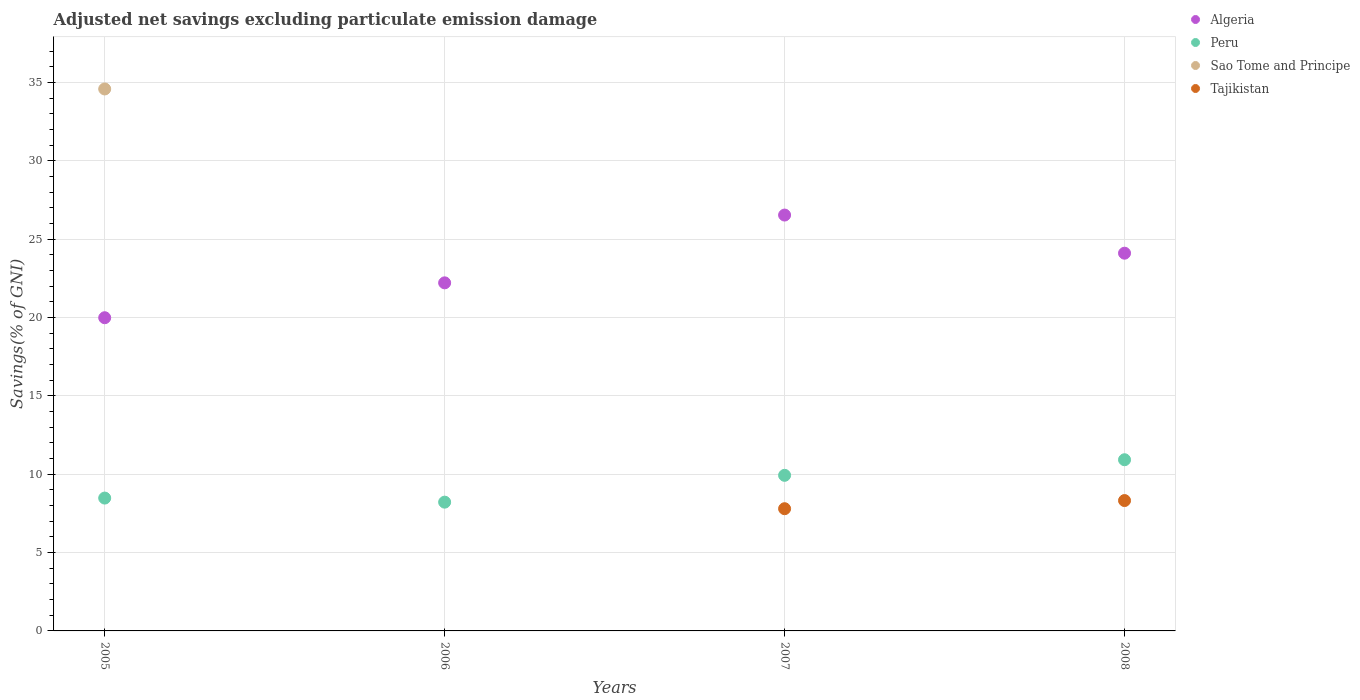How many different coloured dotlines are there?
Ensure brevity in your answer.  4. What is the adjusted net savings in Sao Tome and Principe in 2007?
Keep it short and to the point. 0. Across all years, what is the maximum adjusted net savings in Sao Tome and Principe?
Your answer should be very brief. 34.58. Across all years, what is the minimum adjusted net savings in Algeria?
Your answer should be compact. 19.99. What is the total adjusted net savings in Sao Tome and Principe in the graph?
Give a very brief answer. 34.58. What is the difference between the adjusted net savings in Peru in 2006 and that in 2007?
Your answer should be compact. -1.71. What is the difference between the adjusted net savings in Tajikistan in 2006 and the adjusted net savings in Algeria in 2008?
Provide a succinct answer. -24.1. What is the average adjusted net savings in Peru per year?
Provide a succinct answer. 9.39. In the year 2008, what is the difference between the adjusted net savings in Tajikistan and adjusted net savings in Algeria?
Provide a short and direct response. -15.78. In how many years, is the adjusted net savings in Tajikistan greater than 14 %?
Ensure brevity in your answer.  0. What is the ratio of the adjusted net savings in Peru in 2006 to that in 2007?
Your response must be concise. 0.83. What is the difference between the highest and the second highest adjusted net savings in Peru?
Keep it short and to the point. 0.99. What is the difference between the highest and the lowest adjusted net savings in Algeria?
Keep it short and to the point. 6.55. In how many years, is the adjusted net savings in Algeria greater than the average adjusted net savings in Algeria taken over all years?
Make the answer very short. 2. Is the sum of the adjusted net savings in Algeria in 2005 and 2006 greater than the maximum adjusted net savings in Tajikistan across all years?
Your response must be concise. Yes. Is it the case that in every year, the sum of the adjusted net savings in Sao Tome and Principe and adjusted net savings in Algeria  is greater than the adjusted net savings in Tajikistan?
Make the answer very short. Yes. Does the adjusted net savings in Algeria monotonically increase over the years?
Offer a terse response. No. Is the adjusted net savings in Peru strictly greater than the adjusted net savings in Tajikistan over the years?
Make the answer very short. Yes. Is the adjusted net savings in Algeria strictly less than the adjusted net savings in Peru over the years?
Your response must be concise. No. How many years are there in the graph?
Ensure brevity in your answer.  4. Does the graph contain grids?
Offer a terse response. Yes. Where does the legend appear in the graph?
Keep it short and to the point. Top right. How many legend labels are there?
Make the answer very short. 4. How are the legend labels stacked?
Provide a short and direct response. Vertical. What is the title of the graph?
Ensure brevity in your answer.  Adjusted net savings excluding particulate emission damage. Does "Lower middle income" appear as one of the legend labels in the graph?
Offer a terse response. No. What is the label or title of the Y-axis?
Ensure brevity in your answer.  Savings(% of GNI). What is the Savings(% of GNI) in Algeria in 2005?
Ensure brevity in your answer.  19.99. What is the Savings(% of GNI) of Peru in 2005?
Your answer should be compact. 8.48. What is the Savings(% of GNI) of Sao Tome and Principe in 2005?
Your response must be concise. 34.58. What is the Savings(% of GNI) in Tajikistan in 2005?
Give a very brief answer. 0. What is the Savings(% of GNI) in Algeria in 2006?
Offer a terse response. 22.21. What is the Savings(% of GNI) in Peru in 2006?
Provide a succinct answer. 8.22. What is the Savings(% of GNI) of Sao Tome and Principe in 2006?
Keep it short and to the point. 0. What is the Savings(% of GNI) of Tajikistan in 2006?
Make the answer very short. 0. What is the Savings(% of GNI) of Algeria in 2007?
Keep it short and to the point. 26.54. What is the Savings(% of GNI) in Peru in 2007?
Give a very brief answer. 9.93. What is the Savings(% of GNI) in Sao Tome and Principe in 2007?
Offer a terse response. 0. What is the Savings(% of GNI) of Tajikistan in 2007?
Keep it short and to the point. 7.8. What is the Savings(% of GNI) of Algeria in 2008?
Your response must be concise. 24.1. What is the Savings(% of GNI) of Peru in 2008?
Offer a very short reply. 10.92. What is the Savings(% of GNI) of Sao Tome and Principe in 2008?
Provide a succinct answer. 0. What is the Savings(% of GNI) in Tajikistan in 2008?
Provide a short and direct response. 8.32. Across all years, what is the maximum Savings(% of GNI) of Algeria?
Your answer should be compact. 26.54. Across all years, what is the maximum Savings(% of GNI) of Peru?
Your response must be concise. 10.92. Across all years, what is the maximum Savings(% of GNI) in Sao Tome and Principe?
Your answer should be compact. 34.58. Across all years, what is the maximum Savings(% of GNI) of Tajikistan?
Provide a succinct answer. 8.32. Across all years, what is the minimum Savings(% of GNI) of Algeria?
Keep it short and to the point. 19.99. Across all years, what is the minimum Savings(% of GNI) of Peru?
Your answer should be compact. 8.22. Across all years, what is the minimum Savings(% of GNI) in Tajikistan?
Offer a terse response. 0. What is the total Savings(% of GNI) of Algeria in the graph?
Provide a short and direct response. 92.84. What is the total Savings(% of GNI) of Peru in the graph?
Your answer should be compact. 37.55. What is the total Savings(% of GNI) in Sao Tome and Principe in the graph?
Your response must be concise. 34.58. What is the total Savings(% of GNI) of Tajikistan in the graph?
Give a very brief answer. 16.12. What is the difference between the Savings(% of GNI) of Algeria in 2005 and that in 2006?
Ensure brevity in your answer.  -2.23. What is the difference between the Savings(% of GNI) of Peru in 2005 and that in 2006?
Make the answer very short. 0.26. What is the difference between the Savings(% of GNI) of Algeria in 2005 and that in 2007?
Your answer should be very brief. -6.55. What is the difference between the Savings(% of GNI) of Peru in 2005 and that in 2007?
Provide a succinct answer. -1.45. What is the difference between the Savings(% of GNI) of Algeria in 2005 and that in 2008?
Give a very brief answer. -4.12. What is the difference between the Savings(% of GNI) of Peru in 2005 and that in 2008?
Your response must be concise. -2.45. What is the difference between the Savings(% of GNI) in Algeria in 2006 and that in 2007?
Ensure brevity in your answer.  -4.33. What is the difference between the Savings(% of GNI) in Peru in 2006 and that in 2007?
Ensure brevity in your answer.  -1.71. What is the difference between the Savings(% of GNI) in Algeria in 2006 and that in 2008?
Give a very brief answer. -1.89. What is the difference between the Savings(% of GNI) in Peru in 2006 and that in 2008?
Offer a very short reply. -2.71. What is the difference between the Savings(% of GNI) of Algeria in 2007 and that in 2008?
Offer a very short reply. 2.43. What is the difference between the Savings(% of GNI) in Peru in 2007 and that in 2008?
Offer a terse response. -0.99. What is the difference between the Savings(% of GNI) in Tajikistan in 2007 and that in 2008?
Your response must be concise. -0.52. What is the difference between the Savings(% of GNI) in Algeria in 2005 and the Savings(% of GNI) in Peru in 2006?
Offer a terse response. 11.77. What is the difference between the Savings(% of GNI) in Algeria in 2005 and the Savings(% of GNI) in Peru in 2007?
Make the answer very short. 10.06. What is the difference between the Savings(% of GNI) of Algeria in 2005 and the Savings(% of GNI) of Tajikistan in 2007?
Ensure brevity in your answer.  12.19. What is the difference between the Savings(% of GNI) of Peru in 2005 and the Savings(% of GNI) of Tajikistan in 2007?
Offer a very short reply. 0.68. What is the difference between the Savings(% of GNI) in Sao Tome and Principe in 2005 and the Savings(% of GNI) in Tajikistan in 2007?
Make the answer very short. 26.78. What is the difference between the Savings(% of GNI) in Algeria in 2005 and the Savings(% of GNI) in Peru in 2008?
Offer a terse response. 9.06. What is the difference between the Savings(% of GNI) in Algeria in 2005 and the Savings(% of GNI) in Tajikistan in 2008?
Offer a very short reply. 11.67. What is the difference between the Savings(% of GNI) of Peru in 2005 and the Savings(% of GNI) of Tajikistan in 2008?
Provide a succinct answer. 0.16. What is the difference between the Savings(% of GNI) in Sao Tome and Principe in 2005 and the Savings(% of GNI) in Tajikistan in 2008?
Offer a very short reply. 26.26. What is the difference between the Savings(% of GNI) in Algeria in 2006 and the Savings(% of GNI) in Peru in 2007?
Offer a terse response. 12.28. What is the difference between the Savings(% of GNI) of Algeria in 2006 and the Savings(% of GNI) of Tajikistan in 2007?
Provide a succinct answer. 14.41. What is the difference between the Savings(% of GNI) of Peru in 2006 and the Savings(% of GNI) of Tajikistan in 2007?
Provide a short and direct response. 0.42. What is the difference between the Savings(% of GNI) in Algeria in 2006 and the Savings(% of GNI) in Peru in 2008?
Offer a very short reply. 11.29. What is the difference between the Savings(% of GNI) of Algeria in 2006 and the Savings(% of GNI) of Tajikistan in 2008?
Offer a very short reply. 13.89. What is the difference between the Savings(% of GNI) of Peru in 2006 and the Savings(% of GNI) of Tajikistan in 2008?
Your answer should be compact. -0.1. What is the difference between the Savings(% of GNI) in Algeria in 2007 and the Savings(% of GNI) in Peru in 2008?
Give a very brief answer. 15.61. What is the difference between the Savings(% of GNI) in Algeria in 2007 and the Savings(% of GNI) in Tajikistan in 2008?
Make the answer very short. 18.22. What is the difference between the Savings(% of GNI) of Peru in 2007 and the Savings(% of GNI) of Tajikistan in 2008?
Your response must be concise. 1.61. What is the average Savings(% of GNI) in Algeria per year?
Provide a short and direct response. 23.21. What is the average Savings(% of GNI) of Peru per year?
Your answer should be very brief. 9.39. What is the average Savings(% of GNI) in Sao Tome and Principe per year?
Provide a succinct answer. 8.65. What is the average Savings(% of GNI) in Tajikistan per year?
Your answer should be very brief. 4.03. In the year 2005, what is the difference between the Savings(% of GNI) of Algeria and Savings(% of GNI) of Peru?
Provide a succinct answer. 11.51. In the year 2005, what is the difference between the Savings(% of GNI) of Algeria and Savings(% of GNI) of Sao Tome and Principe?
Offer a terse response. -14.6. In the year 2005, what is the difference between the Savings(% of GNI) of Peru and Savings(% of GNI) of Sao Tome and Principe?
Keep it short and to the point. -26.11. In the year 2006, what is the difference between the Savings(% of GNI) in Algeria and Savings(% of GNI) in Peru?
Make the answer very short. 13.99. In the year 2007, what is the difference between the Savings(% of GNI) of Algeria and Savings(% of GNI) of Peru?
Provide a short and direct response. 16.61. In the year 2007, what is the difference between the Savings(% of GNI) of Algeria and Savings(% of GNI) of Tajikistan?
Offer a very short reply. 18.74. In the year 2007, what is the difference between the Savings(% of GNI) of Peru and Savings(% of GNI) of Tajikistan?
Keep it short and to the point. 2.13. In the year 2008, what is the difference between the Savings(% of GNI) of Algeria and Savings(% of GNI) of Peru?
Keep it short and to the point. 13.18. In the year 2008, what is the difference between the Savings(% of GNI) of Algeria and Savings(% of GNI) of Tajikistan?
Make the answer very short. 15.79. In the year 2008, what is the difference between the Savings(% of GNI) of Peru and Savings(% of GNI) of Tajikistan?
Your answer should be very brief. 2.6. What is the ratio of the Savings(% of GNI) in Algeria in 2005 to that in 2006?
Your response must be concise. 0.9. What is the ratio of the Savings(% of GNI) in Peru in 2005 to that in 2006?
Provide a short and direct response. 1.03. What is the ratio of the Savings(% of GNI) of Algeria in 2005 to that in 2007?
Offer a terse response. 0.75. What is the ratio of the Savings(% of GNI) of Peru in 2005 to that in 2007?
Your answer should be compact. 0.85. What is the ratio of the Savings(% of GNI) in Algeria in 2005 to that in 2008?
Your answer should be very brief. 0.83. What is the ratio of the Savings(% of GNI) in Peru in 2005 to that in 2008?
Give a very brief answer. 0.78. What is the ratio of the Savings(% of GNI) in Algeria in 2006 to that in 2007?
Provide a succinct answer. 0.84. What is the ratio of the Savings(% of GNI) in Peru in 2006 to that in 2007?
Keep it short and to the point. 0.83. What is the ratio of the Savings(% of GNI) of Algeria in 2006 to that in 2008?
Make the answer very short. 0.92. What is the ratio of the Savings(% of GNI) in Peru in 2006 to that in 2008?
Offer a terse response. 0.75. What is the ratio of the Savings(% of GNI) of Algeria in 2007 to that in 2008?
Make the answer very short. 1.1. What is the ratio of the Savings(% of GNI) in Peru in 2007 to that in 2008?
Your response must be concise. 0.91. What is the ratio of the Savings(% of GNI) of Tajikistan in 2007 to that in 2008?
Provide a short and direct response. 0.94. What is the difference between the highest and the second highest Savings(% of GNI) of Algeria?
Give a very brief answer. 2.43. What is the difference between the highest and the lowest Savings(% of GNI) in Algeria?
Your answer should be compact. 6.55. What is the difference between the highest and the lowest Savings(% of GNI) in Peru?
Your response must be concise. 2.71. What is the difference between the highest and the lowest Savings(% of GNI) in Sao Tome and Principe?
Give a very brief answer. 34.58. What is the difference between the highest and the lowest Savings(% of GNI) of Tajikistan?
Keep it short and to the point. 8.32. 